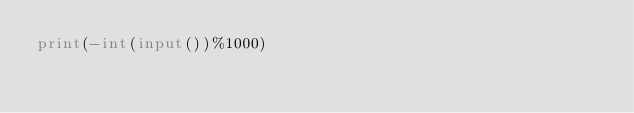<code> <loc_0><loc_0><loc_500><loc_500><_Python_>print(-int(input())%1000)
</code> 